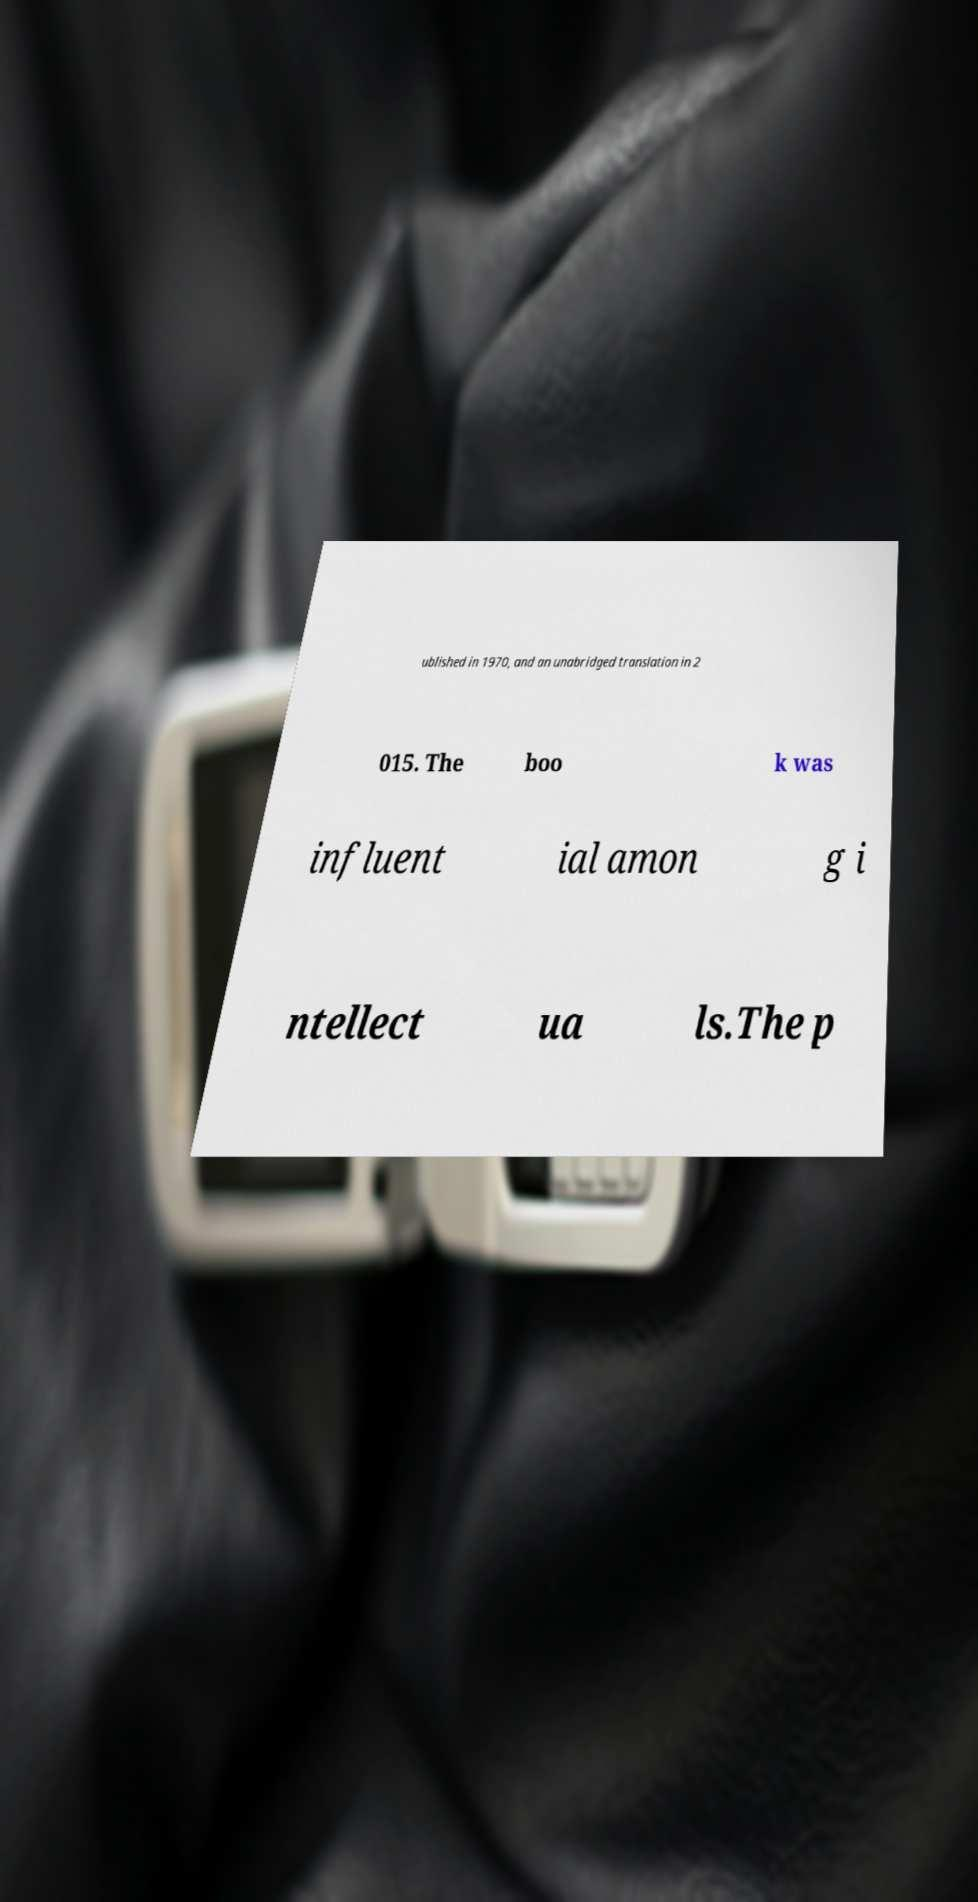Could you assist in decoding the text presented in this image and type it out clearly? ublished in 1970, and an unabridged translation in 2 015. The boo k was influent ial amon g i ntellect ua ls.The p 